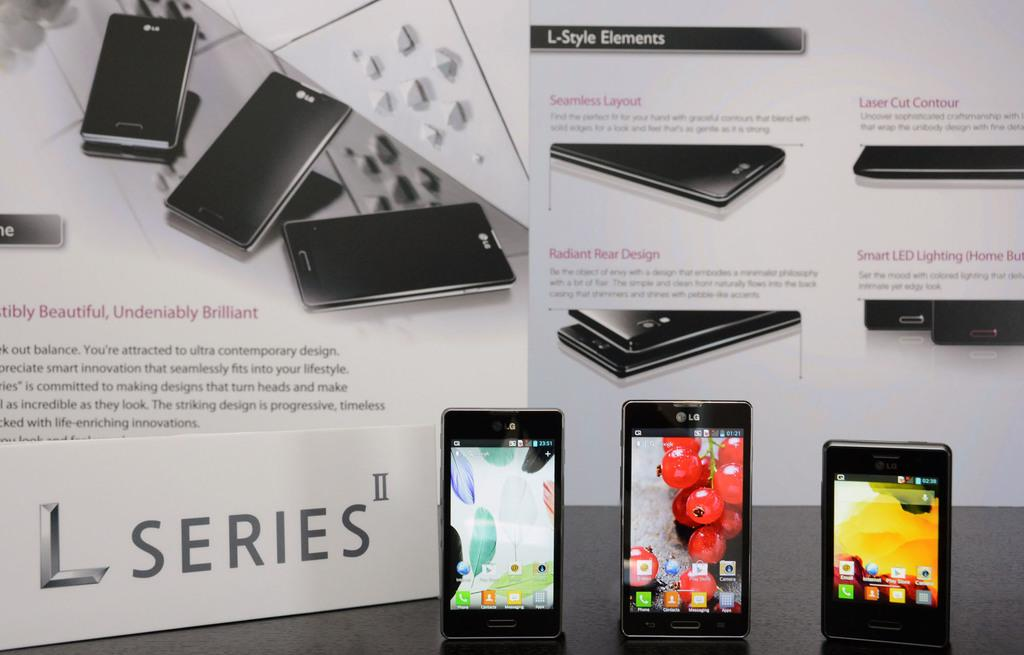<image>
Write a terse but informative summary of the picture. a phone which has L series written on it 